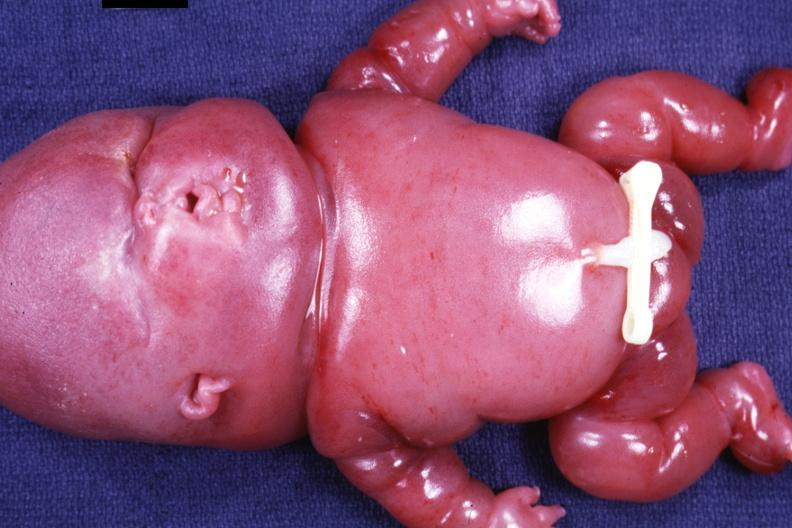does this image show anterior view of whole body?
Answer the question using a single word or phrase. Yes 